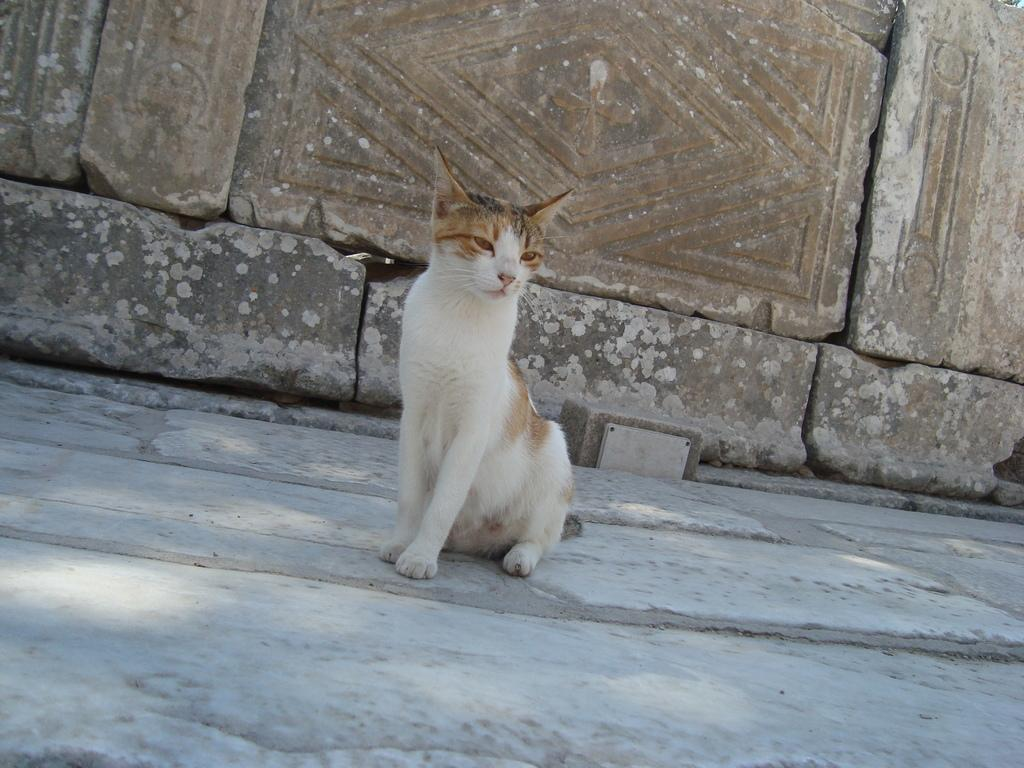What type of animal is on the ground in the image? There is a cat on the ground in the image. What can be seen in the background of the image? There is a wall with bricks in the background. What type of circle can be seen in the image? There is no circle present in the image. Is the cat shown swinging from a tree branch in the image? No, the cat is on the ground, and there is no tree branch or swing present in the image. 